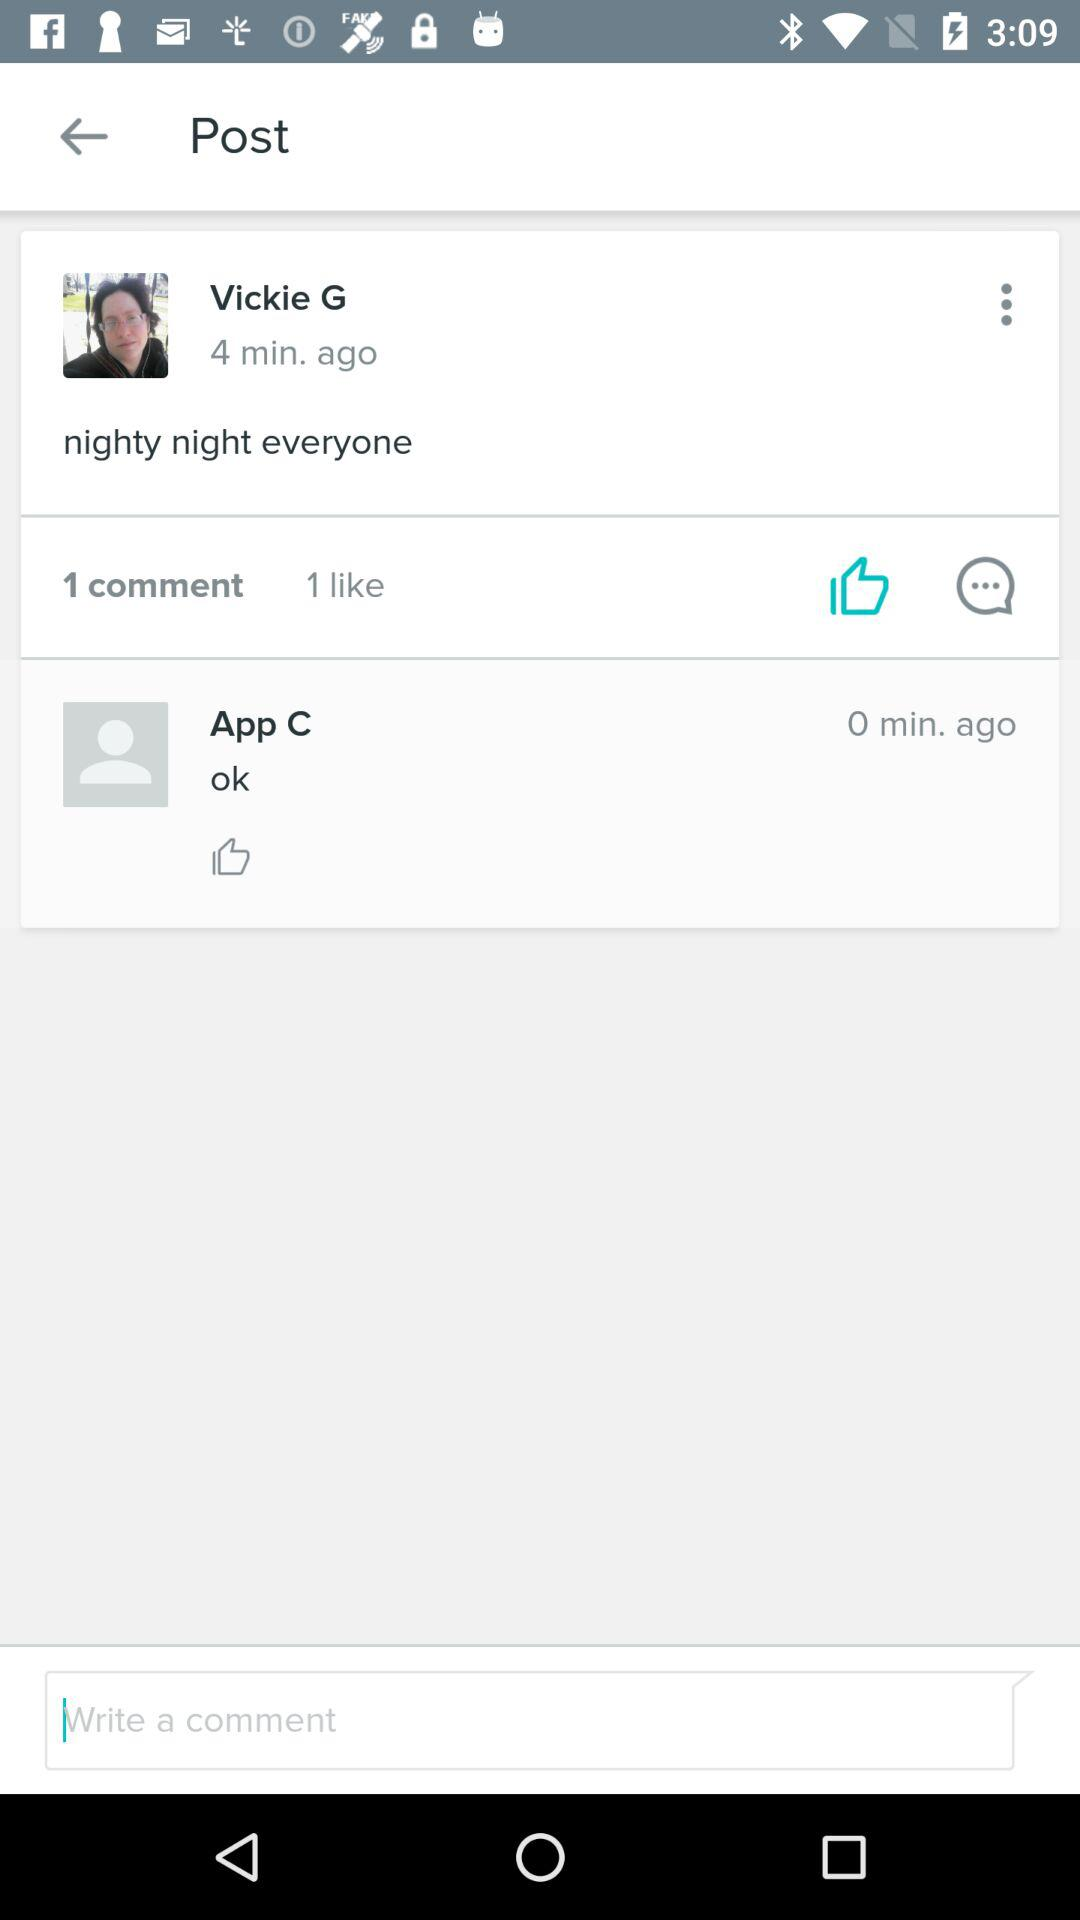What is the name of the application?
When the provided information is insufficient, respond with <no answer>. <no answer> 